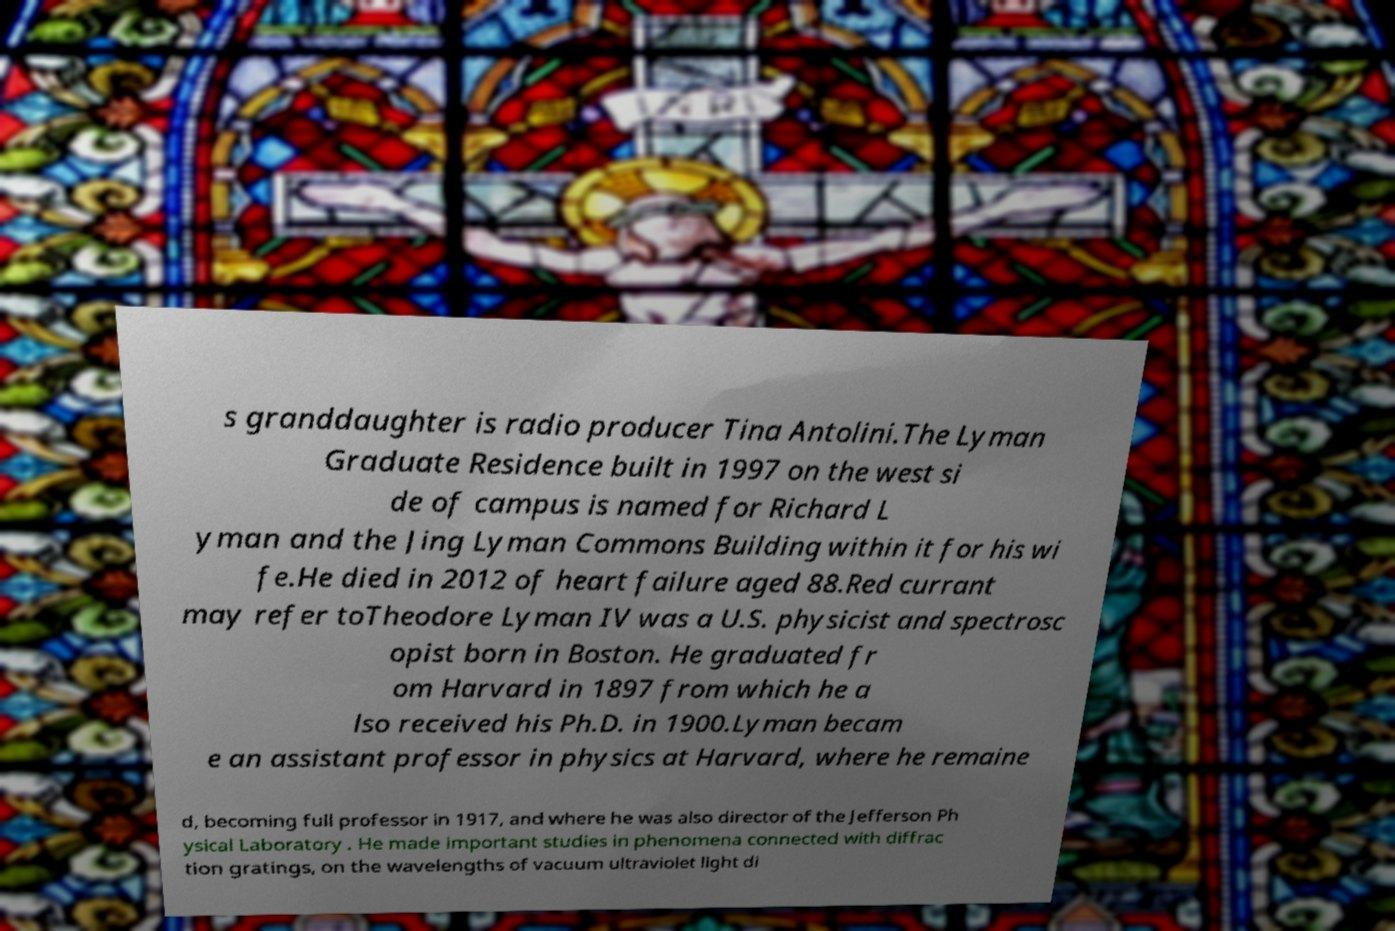Can you read and provide the text displayed in the image?This photo seems to have some interesting text. Can you extract and type it out for me? s granddaughter is radio producer Tina Antolini.The Lyman Graduate Residence built in 1997 on the west si de of campus is named for Richard L yman and the Jing Lyman Commons Building within it for his wi fe.He died in 2012 of heart failure aged 88.Red currant may refer toTheodore Lyman IV was a U.S. physicist and spectrosc opist born in Boston. He graduated fr om Harvard in 1897 from which he a lso received his Ph.D. in 1900.Lyman becam e an assistant professor in physics at Harvard, where he remaine d, becoming full professor in 1917, and where he was also director of the Jefferson Ph ysical Laboratory . He made important studies in phenomena connected with diffrac tion gratings, on the wavelengths of vacuum ultraviolet light di 